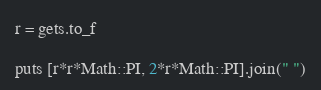<code> <loc_0><loc_0><loc_500><loc_500><_Ruby_>r = gets.to_f

puts [r*r*Math::PI, 2*r*Math::PI].join(" ")</code> 